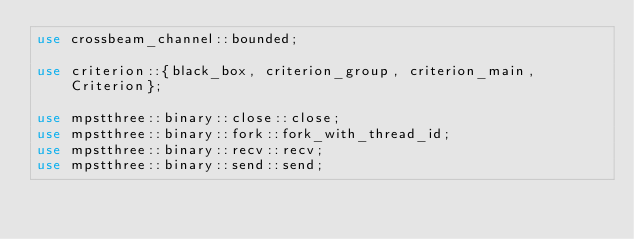<code> <loc_0><loc_0><loc_500><loc_500><_Rust_>use crossbeam_channel::bounded;

use criterion::{black_box, criterion_group, criterion_main, Criterion};

use mpstthree::binary::close::close;
use mpstthree::binary::fork::fork_with_thread_id;
use mpstthree::binary::recv::recv;
use mpstthree::binary::send::send;</code> 